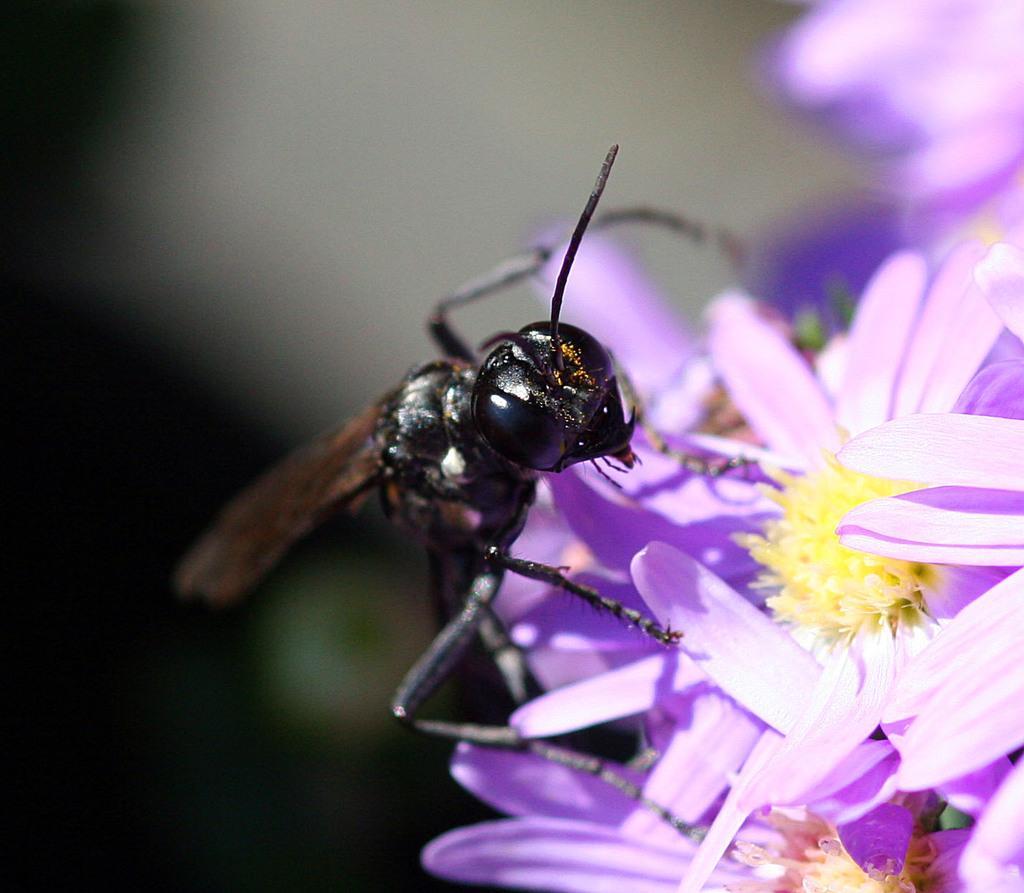Please provide a concise description of this image. In this image we can see an insect on group of flowers. 